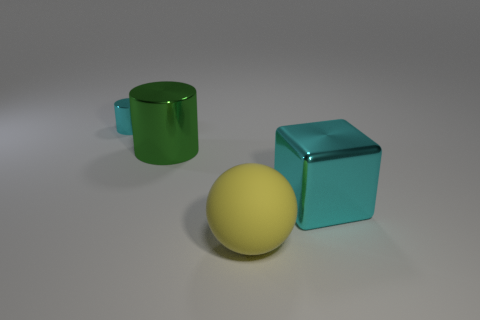Can you describe the shapes and their colors shown in the image? Certainly! The image displays three objects: a green cylinder, which resembles a mug without a handle; a yellow sphere with a smooth texture that suggests it's a rubber ball; and a cyan cube with a reflective surface that could possibly be made of glass or polished metal. 